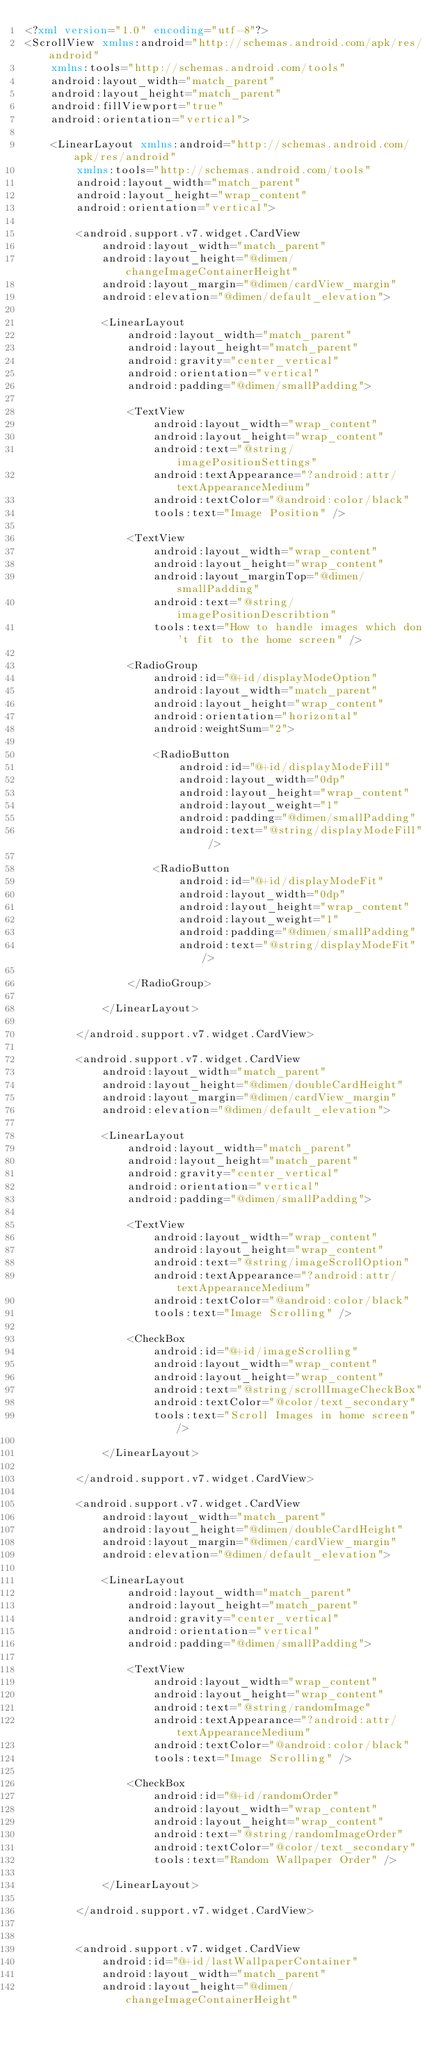<code> <loc_0><loc_0><loc_500><loc_500><_XML_><?xml version="1.0" encoding="utf-8"?>
<ScrollView xmlns:android="http://schemas.android.com/apk/res/android"
    xmlns:tools="http://schemas.android.com/tools"
    android:layout_width="match_parent"
    android:layout_height="match_parent"
    android:fillViewport="true"
    android:orientation="vertical">

    <LinearLayout xmlns:android="http://schemas.android.com/apk/res/android"
        xmlns:tools="http://schemas.android.com/tools"
        android:layout_width="match_parent"
        android:layout_height="wrap_content"
        android:orientation="vertical">

        <android.support.v7.widget.CardView
            android:layout_width="match_parent"
            android:layout_height="@dimen/changeImageContainerHeight"
            android:layout_margin="@dimen/cardView_margin"
            android:elevation="@dimen/default_elevation">

            <LinearLayout
                android:layout_width="match_parent"
                android:layout_height="match_parent"
                android:gravity="center_vertical"
                android:orientation="vertical"
                android:padding="@dimen/smallPadding">

                <TextView
                    android:layout_width="wrap_content"
                    android:layout_height="wrap_content"
                    android:text="@string/imagePositionSettings"
                    android:textAppearance="?android:attr/textAppearanceMedium"
                    android:textColor="@android:color/black"
                    tools:text="Image Position" />

                <TextView
                    android:layout_width="wrap_content"
                    android:layout_height="wrap_content"
                    android:layout_marginTop="@dimen/smallPadding"
                    android:text="@string/imagePositionDescribtion"
                    tools:text="How to handle images which don't fit to the home screen" />

                <RadioGroup
                    android:id="@+id/displayModeOption"
                    android:layout_width="match_parent"
                    android:layout_height="wrap_content"
                    android:orientation="horizontal"
                    android:weightSum="2">

                    <RadioButton
                        android:id="@+id/displayModeFill"
                        android:layout_width="0dp"
                        android:layout_height="wrap_content"
                        android:layout_weight="1"
                        android:padding="@dimen/smallPadding"
                        android:text="@string/displayModeFill" />

                    <RadioButton
                        android:id="@+id/displayModeFit"
                        android:layout_width="0dp"
                        android:layout_height="wrap_content"
                        android:layout_weight="1"
                        android:padding="@dimen/smallPadding"
                        android:text="@string/displayModeFit" />

                </RadioGroup>

            </LinearLayout>

        </android.support.v7.widget.CardView>

        <android.support.v7.widget.CardView
            android:layout_width="match_parent"
            android:layout_height="@dimen/doubleCardHeight"
            android:layout_margin="@dimen/cardView_margin"
            android:elevation="@dimen/default_elevation">

            <LinearLayout
                android:layout_width="match_parent"
                android:layout_height="match_parent"
                android:gravity="center_vertical"
                android:orientation="vertical"
                android:padding="@dimen/smallPadding">

                <TextView
                    android:layout_width="wrap_content"
                    android:layout_height="wrap_content"
                    android:text="@string/imageScrollOption"
                    android:textAppearance="?android:attr/textAppearanceMedium"
                    android:textColor="@android:color/black"
                    tools:text="Image Scrolling" />

                <CheckBox
                    android:id="@+id/imageScrolling"
                    android:layout_width="wrap_content"
                    android:layout_height="wrap_content"
                    android:text="@string/scrollImageCheckBox"
                    android:textColor="@color/text_secondary"
                    tools:text="Scroll Images in home screen" />

            </LinearLayout>

        </android.support.v7.widget.CardView>

        <android.support.v7.widget.CardView
            android:layout_width="match_parent"
            android:layout_height="@dimen/doubleCardHeight"
            android:layout_margin="@dimen/cardView_margin"
            android:elevation="@dimen/default_elevation">

            <LinearLayout
                android:layout_width="match_parent"
                android:layout_height="match_parent"
                android:gravity="center_vertical"
                android:orientation="vertical"
                android:padding="@dimen/smallPadding">

                <TextView
                    android:layout_width="wrap_content"
                    android:layout_height="wrap_content"
                    android:text="@string/randomImage"
                    android:textAppearance="?android:attr/textAppearanceMedium"
                    android:textColor="@android:color/black"
                    tools:text="Image Scrolling" />

                <CheckBox
                    android:id="@+id/randomOrder"
                    android:layout_width="wrap_content"
                    android:layout_height="wrap_content"
                    android:text="@string/randomImageOrder"
                    android:textColor="@color/text_secondary"
                    tools:text="Random Wallpaper Order" />

            </LinearLayout>

        </android.support.v7.widget.CardView>


        <android.support.v7.widget.CardView
            android:id="@+id/lastWallpaperContainer"
            android:layout_width="match_parent"
            android:layout_height="@dimen/changeImageContainerHeight"</code> 